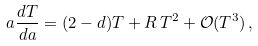Convert formula to latex. <formula><loc_0><loc_0><loc_500><loc_500>a \frac { d T } { d a } = ( 2 - d ) T + R \, T ^ { 2 } + \mathcal { O } ( T ^ { 3 } ) \, ,</formula> 